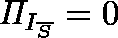<formula> <loc_0><loc_0><loc_500><loc_500>\Pi _ { I _ { \overline { S } } } = 0</formula> 